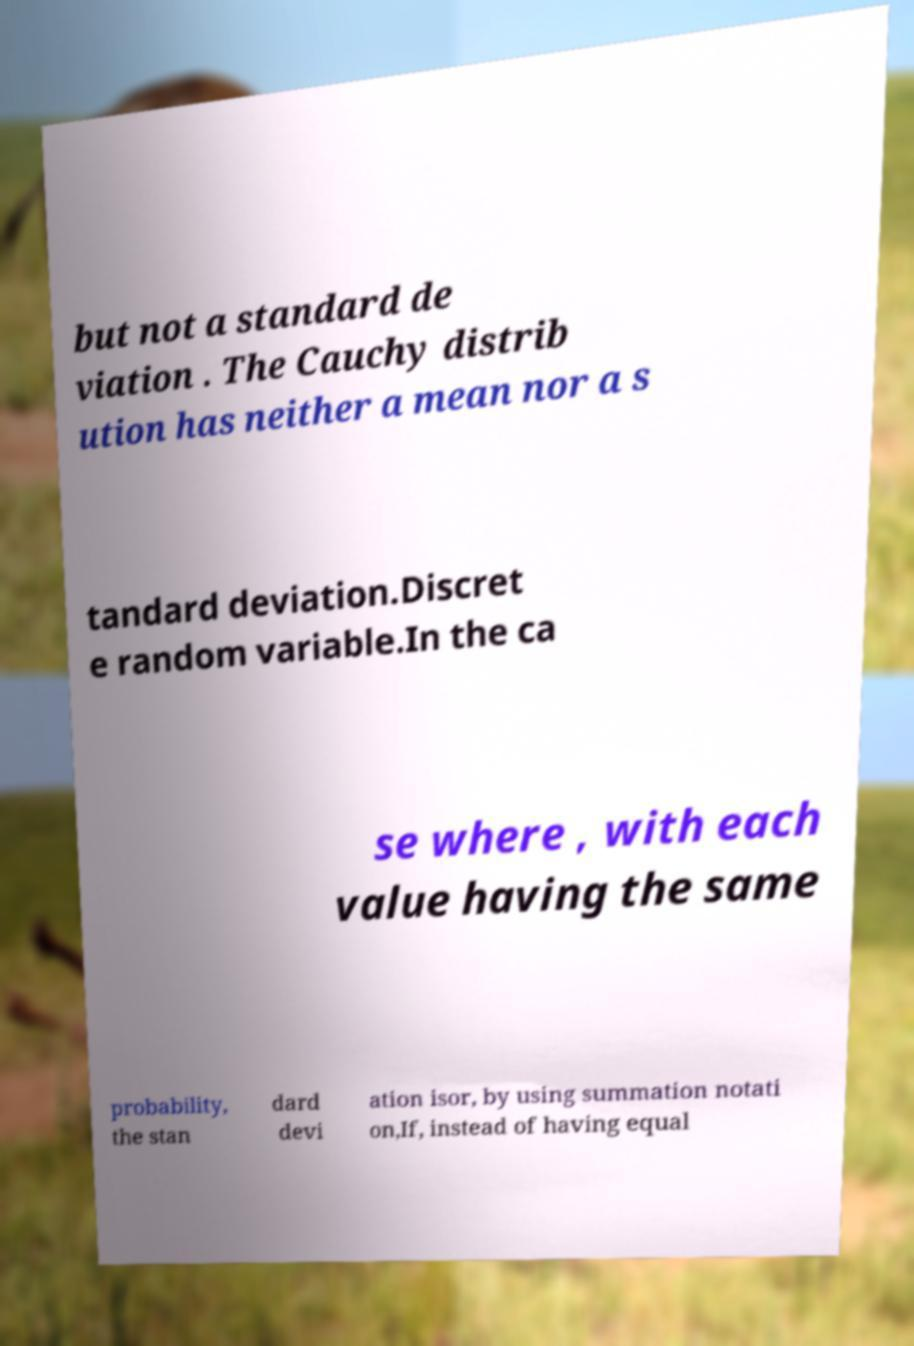For documentation purposes, I need the text within this image transcribed. Could you provide that? but not a standard de viation . The Cauchy distrib ution has neither a mean nor a s tandard deviation.Discret e random variable.In the ca se where , with each value having the same probability, the stan dard devi ation isor, by using summation notati on,If, instead of having equal 